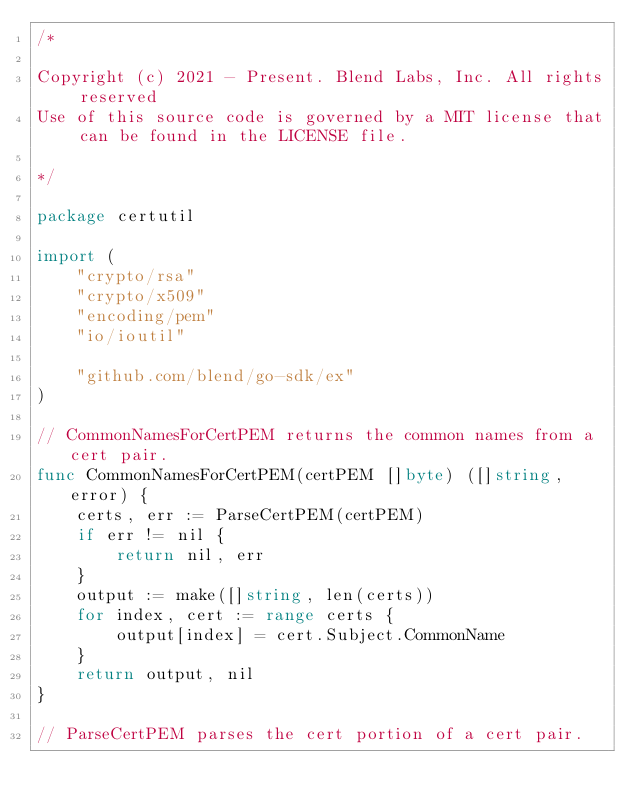Convert code to text. <code><loc_0><loc_0><loc_500><loc_500><_Go_>/*

Copyright (c) 2021 - Present. Blend Labs, Inc. All rights reserved
Use of this source code is governed by a MIT license that can be found in the LICENSE file.

*/

package certutil

import (
	"crypto/rsa"
	"crypto/x509"
	"encoding/pem"
	"io/ioutil"

	"github.com/blend/go-sdk/ex"
)

// CommonNamesForCertPEM returns the common names from a cert pair.
func CommonNamesForCertPEM(certPEM []byte) ([]string, error) {
	certs, err := ParseCertPEM(certPEM)
	if err != nil {
		return nil, err
	}
	output := make([]string, len(certs))
	for index, cert := range certs {
		output[index] = cert.Subject.CommonName
	}
	return output, nil
}

// ParseCertPEM parses the cert portion of a cert pair.</code> 